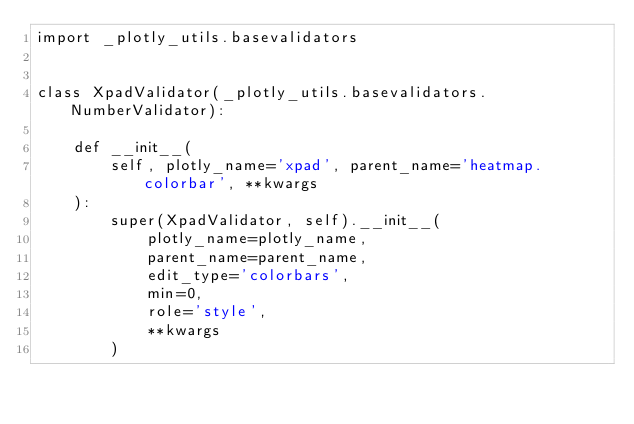Convert code to text. <code><loc_0><loc_0><loc_500><loc_500><_Python_>import _plotly_utils.basevalidators


class XpadValidator(_plotly_utils.basevalidators.NumberValidator):

    def __init__(
        self, plotly_name='xpad', parent_name='heatmap.colorbar', **kwargs
    ):
        super(XpadValidator, self).__init__(
            plotly_name=plotly_name,
            parent_name=parent_name,
            edit_type='colorbars',
            min=0,
            role='style',
            **kwargs
        )
</code> 